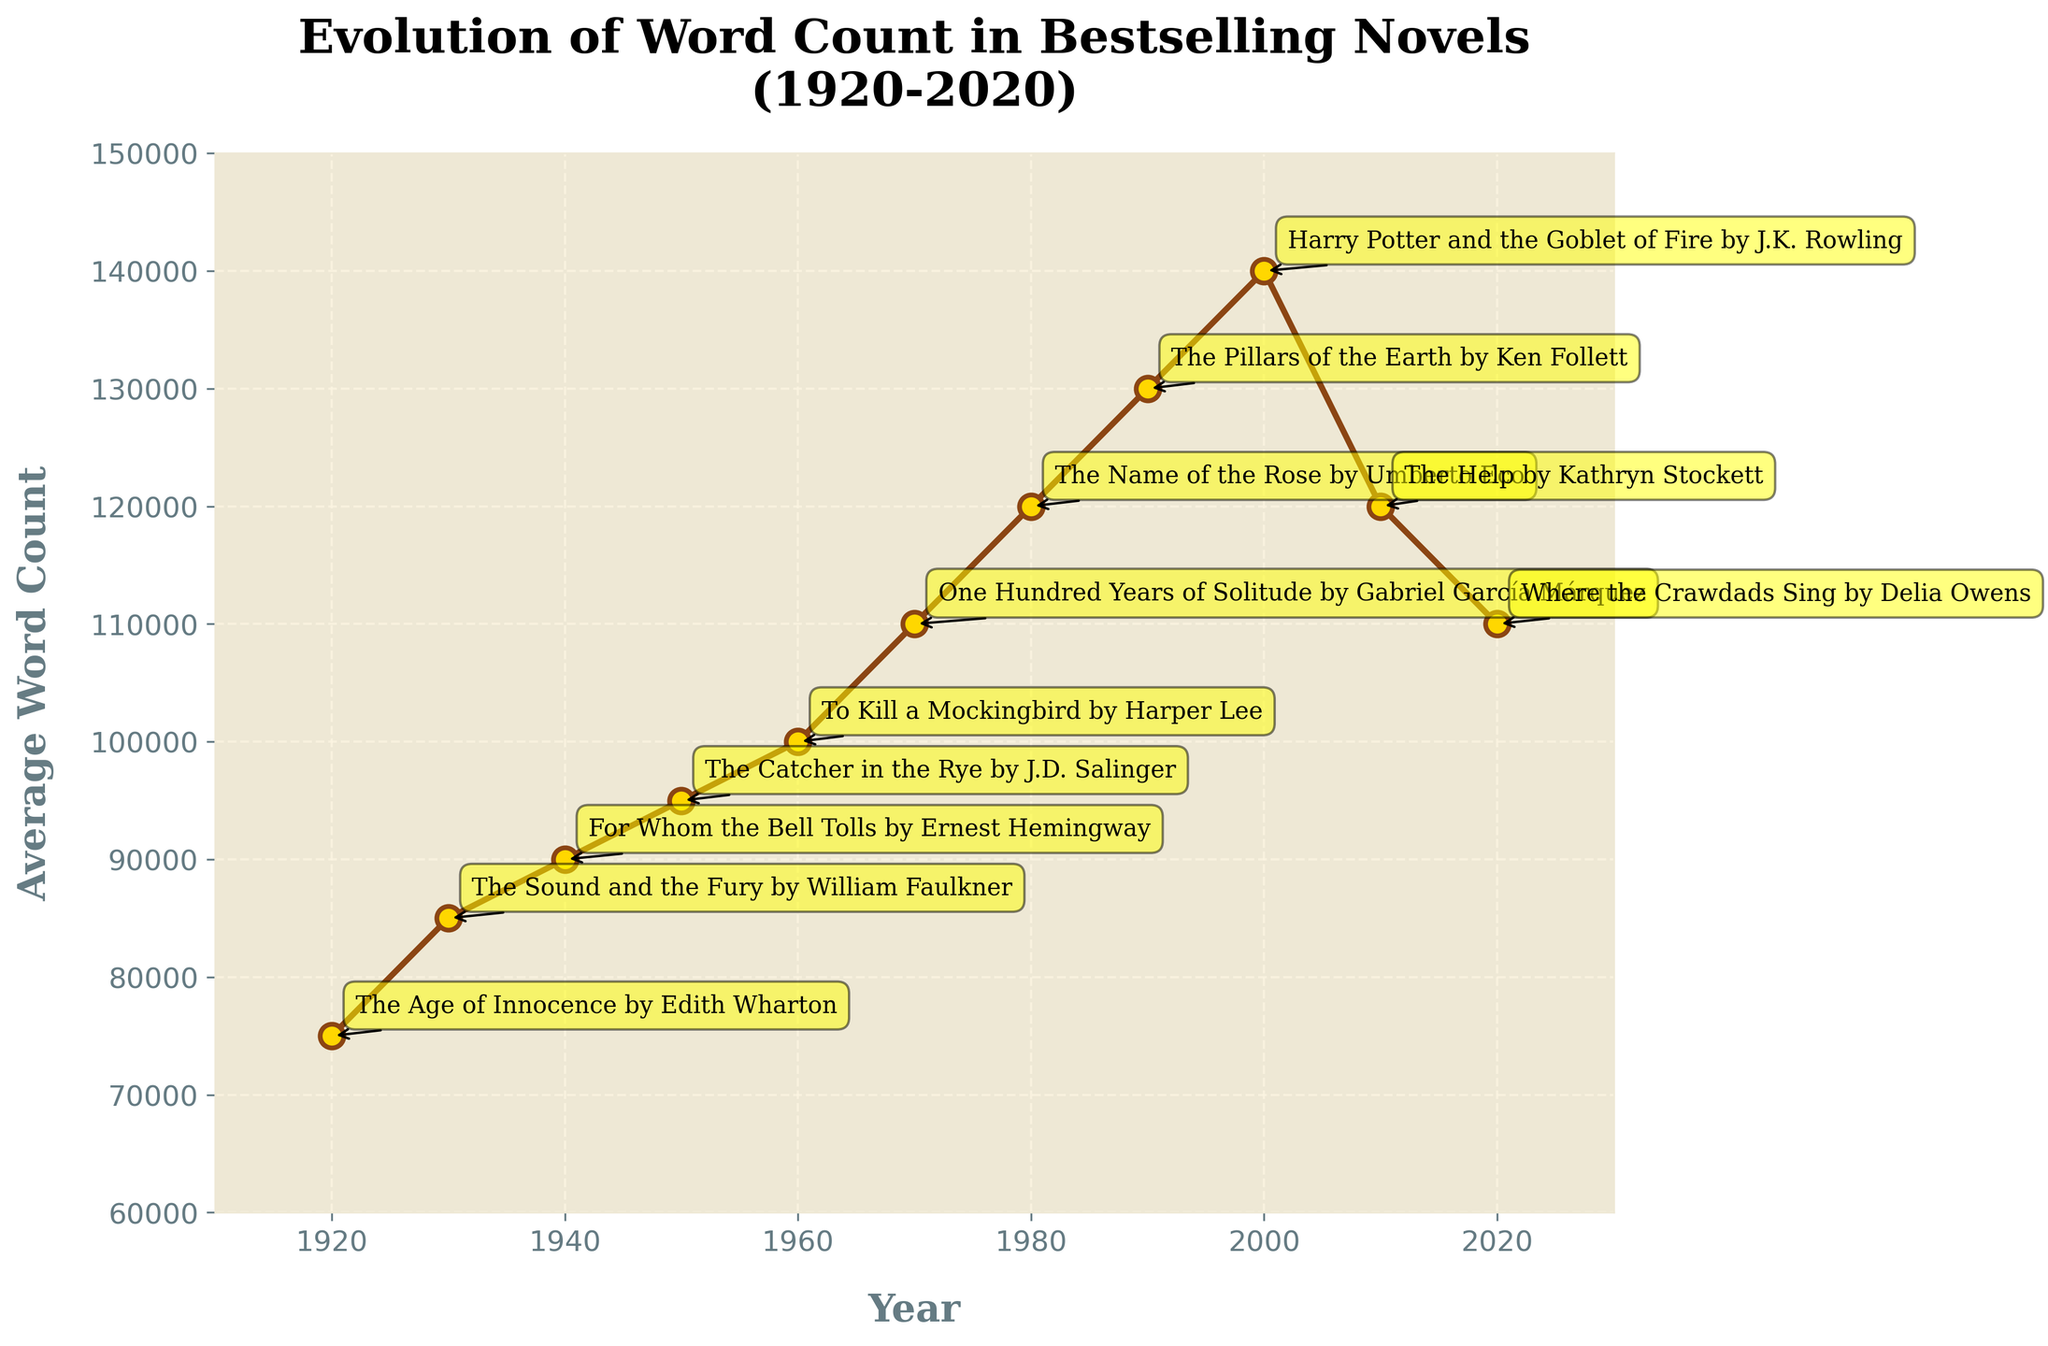How did the average word count in bestselling novels change from 1920 to 1950? From the figure, observe the word counts in 1920 (75,000) and 1950 (95,000). The change can be calculated as 95,000 - 75,000. So, the average word count increased by 20,000 words from 1920 to 1950.
Answer: Increased by 20,000 words Which decade saw the highest average word count for bestselling novels? By looking at the peaks in the chart, the highest point occurs around the year 2000 with an average word count of 140,000. Therefore, the decade with the highest word count is the 2000s.
Answer: 2000s By how much did the average word count decrease from 2000 to 2010? In the year 2000, the average word count was 140,000. By 2010, it had decreased to 120,000. The change can be calculated as 140,000 - 120,000. Thus, the decrease was 20,000 words.
Answer: Decreased by 20,000 words What is the average increase in word count per decade from 1920 to 1970? We observe the word counts in consecutive decades: 1920 (75,000), 1930 (85,000), 1940 (90,000), 1950 (95,000), 1960 (100,000), and 1970 (110,000). The changes are: 1930-1920 (85,000-75,000)=10,000, 1940-1930 (90,000-85,000)=5,000, 1950-1940 (95,000-90,000)=5,000, 1960-1950 (100,000-95,000)=5,000, and 1970-1960 (110,000-100,000)=10,000. The average increase per decade is (10,000+5,000+5,000+5,000+10,000)/5 = 7,000.
Answer: 7,000 words per decade Compare the average word counts between the notable examples "The Age of Innocence by Edith Wharton" and "One Hundred Years of Solitude by Gabriel García Márquez." Which one is greater? "The Age of Innocence by Edith Wharton" (1920) has an average word count of 75,000. "One Hundred Years of Solitude by Gabriel García Márquez" (1970) has an average word count of 110,000. The latter is greater.
Answer: One Hundred Years of Solitude by Gabriel García Márquez Which novel noted in the chart was released in 2020, and what was its average word count? The chart annotation for the year 2020 states "Where the Crawdads Sing by Delia Owens." Its average word count is 110,000.
Answer: Where the Crawdads Sing by Delia Owens, 110,000 Identify the visual trend for the average word count from 1920 to 1960. How would you describe it? By observing the line graph from 1920 to 1960, there is a consistent upward trend in the average word count. It increased from 75,000 in 1920 to 100,000 in 1960.
Answer: Consistently increasing trend What is the difference in the average word count between the peak year 2000 and the ending year 2020? The average word count in 2000 is noted as 140,000, whereas in 2020, it is 110,000. Thus, the difference is calculated as 140,000 - 110,000 = 30,000.
Answer: 30,000 words What is the color of the line used to depict the evolution of the word count in bestselling novels? By observing the figure, the color of the line can be described as brown.
Answer: Brown 